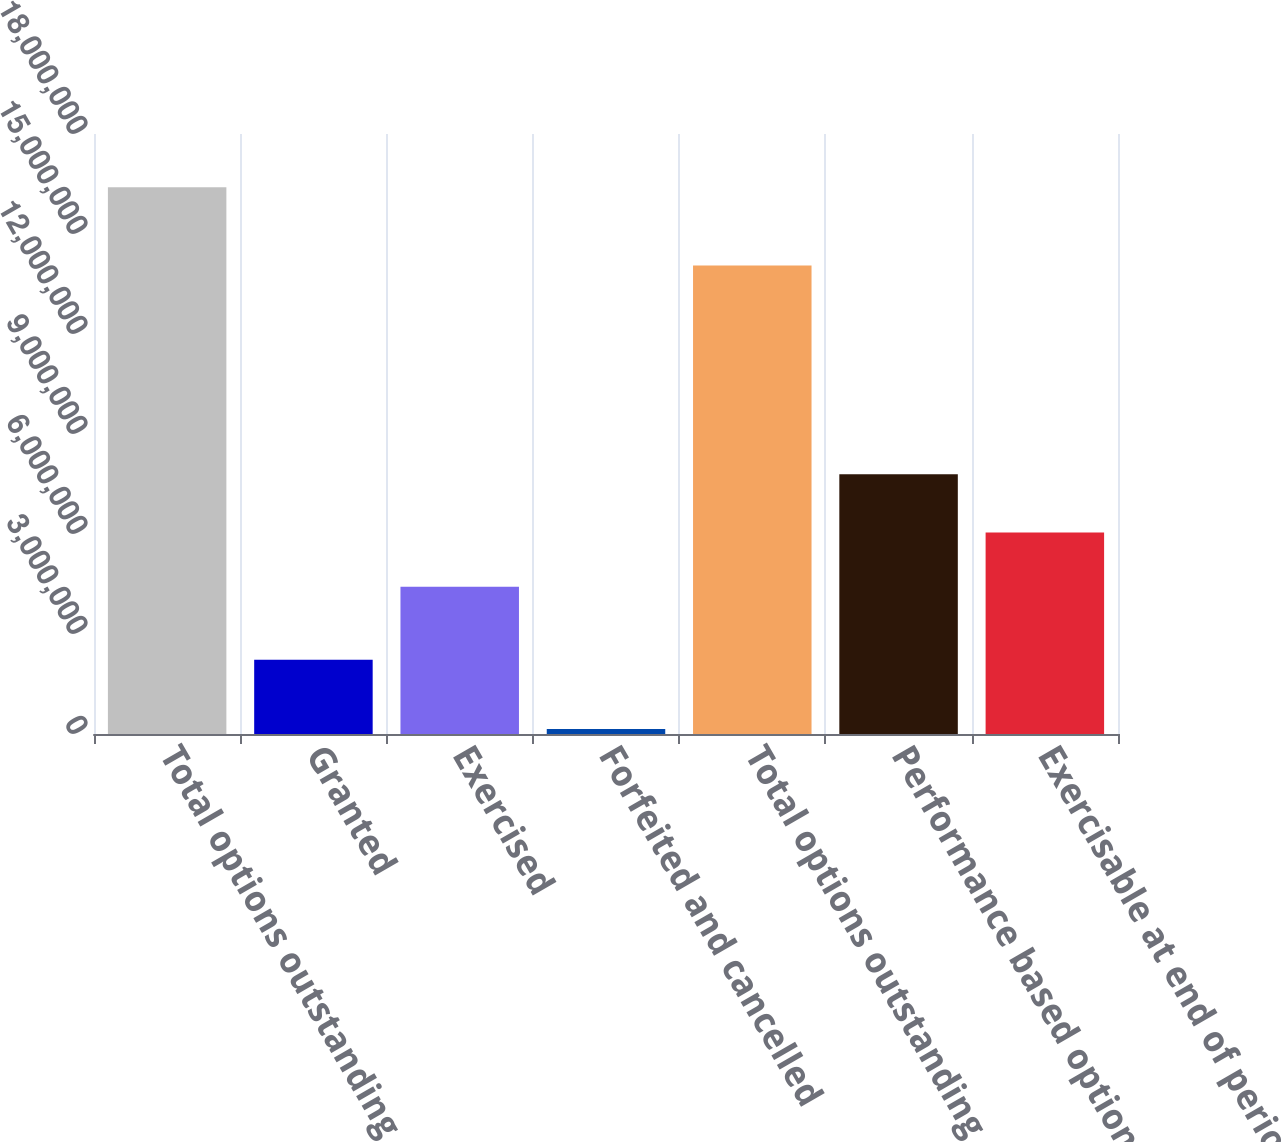Convert chart. <chart><loc_0><loc_0><loc_500><loc_500><bar_chart><fcel>Total options outstanding<fcel>Granted<fcel>Exercised<fcel>Forfeited and cancelled<fcel>Total options outstanding end<fcel>Performance based options<fcel>Exercisable at end of period<nl><fcel>1.63999e+07<fcel>2.2255e+06<fcel>4.4194e+06<fcel>147400<fcel>1.40586e+07<fcel>7.7905e+06<fcel>6.04464e+06<nl></chart> 